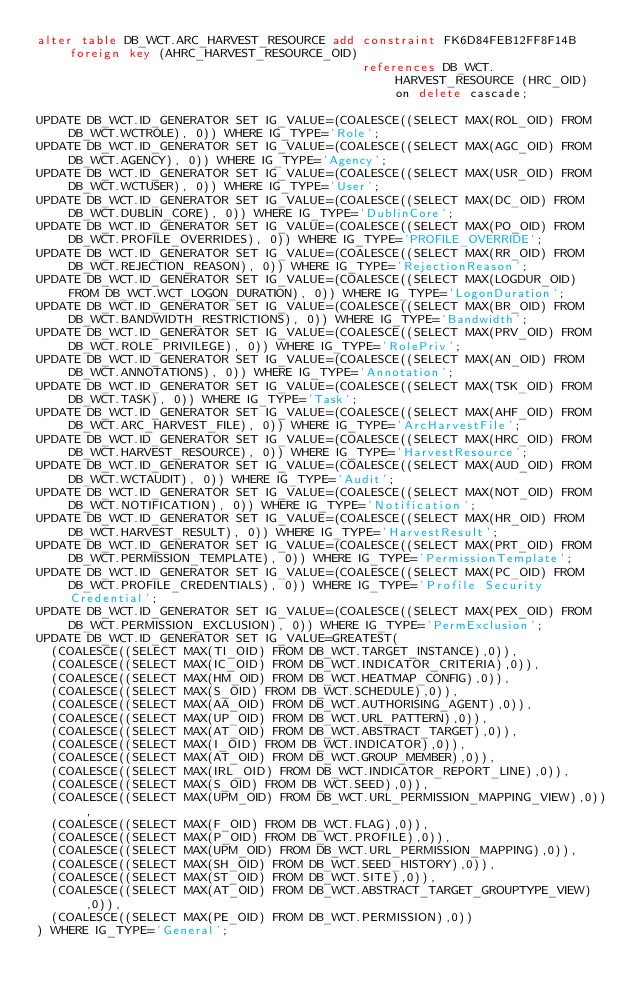<code> <loc_0><loc_0><loc_500><loc_500><_SQL_>alter table DB_WCT.ARC_HARVEST_RESOURCE add constraint FK6D84FEB12FF8F14B foreign key (AHRC_HARVEST_RESOURCE_OID)
                                            references DB_WCT.HARVEST_RESOURCE (HRC_OID) on delete cascade;

UPDATE DB_WCT.ID_GENERATOR SET IG_VALUE=(COALESCE((SELECT MAX(ROL_OID) FROM DB_WCT.WCTROLE), 0)) WHERE IG_TYPE='Role';
UPDATE DB_WCT.ID_GENERATOR SET IG_VALUE=(COALESCE((SELECT MAX(AGC_OID) FROM DB_WCT.AGENCY), 0)) WHERE IG_TYPE='Agency';
UPDATE DB_WCT.ID_GENERATOR SET IG_VALUE=(COALESCE((SELECT MAX(USR_OID) FROM DB_WCT.WCTUSER), 0)) WHERE IG_TYPE='User';
UPDATE DB_WCT.ID_GENERATOR SET IG_VALUE=(COALESCE((SELECT MAX(DC_OID) FROM DB_WCT.DUBLIN_CORE), 0)) WHERE IG_TYPE='DublinCore';
UPDATE DB_WCT.ID_GENERATOR SET IG_VALUE=(COALESCE((SELECT MAX(PO_OID) FROM DB_WCT.PROFILE_OVERRIDES), 0)) WHERE IG_TYPE='PROFILE_OVERRIDE';
UPDATE DB_WCT.ID_GENERATOR SET IG_VALUE=(COALESCE((SELECT MAX(RR_OID) FROM DB_WCT.REJECTION_REASON), 0)) WHERE IG_TYPE='RejectionReason';
UPDATE DB_WCT.ID_GENERATOR SET IG_VALUE=(COALESCE((SELECT MAX(LOGDUR_OID) FROM DB_WCT.WCT_LOGON_DURATION), 0)) WHERE IG_TYPE='LogonDuration';
UPDATE DB_WCT.ID_GENERATOR SET IG_VALUE=(COALESCE((SELECT MAX(BR_OID) FROM DB_WCT.BANDWIDTH_RESTRICTIONS), 0)) WHERE IG_TYPE='Bandwidth';
UPDATE DB_WCT.ID_GENERATOR SET IG_VALUE=(COALESCE((SELECT MAX(PRV_OID) FROM DB_WCT.ROLE_PRIVILEGE), 0)) WHERE IG_TYPE='RolePriv';
UPDATE DB_WCT.ID_GENERATOR SET IG_VALUE=(COALESCE((SELECT MAX(AN_OID) FROM DB_WCT.ANNOTATIONS), 0)) WHERE IG_TYPE='Annotation';
UPDATE DB_WCT.ID_GENERATOR SET IG_VALUE=(COALESCE((SELECT MAX(TSK_OID) FROM DB_WCT.TASK), 0)) WHERE IG_TYPE='Task';
UPDATE DB_WCT.ID_GENERATOR SET IG_VALUE=(COALESCE((SELECT MAX(AHF_OID) FROM DB_WCT.ARC_HARVEST_FILE), 0)) WHERE IG_TYPE='ArcHarvestFile';
UPDATE DB_WCT.ID_GENERATOR SET IG_VALUE=(COALESCE((SELECT MAX(HRC_OID) FROM DB_WCT.HARVEST_RESOURCE), 0)) WHERE IG_TYPE='HarvestResource';
UPDATE DB_WCT.ID_GENERATOR SET IG_VALUE=(COALESCE((SELECT MAX(AUD_OID) FROM DB_WCT.WCTAUDIT), 0)) WHERE IG_TYPE='Audit';
UPDATE DB_WCT.ID_GENERATOR SET IG_VALUE=(COALESCE((SELECT MAX(NOT_OID) FROM DB_WCT.NOTIFICATION), 0)) WHERE IG_TYPE='Notification';
UPDATE DB_WCT.ID_GENERATOR SET IG_VALUE=(COALESCE((SELECT MAX(HR_OID) FROM DB_WCT.HARVEST_RESULT), 0)) WHERE IG_TYPE='HarvestResult';
UPDATE DB_WCT.ID_GENERATOR SET IG_VALUE=(COALESCE((SELECT MAX(PRT_OID) FROM DB_WCT.PERMISSION_TEMPLATE), 0)) WHERE IG_TYPE='PermissionTemplate';
UPDATE DB_WCT.ID_GENERATOR SET IG_VALUE=(COALESCE((SELECT MAX(PC_OID) FROM DB_WCT.PROFILE_CREDENTIALS), 0)) WHERE IG_TYPE='Profile Security Credential';
UPDATE DB_WCT.ID_GENERATOR SET IG_VALUE=(COALESCE((SELECT MAX(PEX_OID) FROM DB_WCT.PERMISSION_EXCLUSION), 0)) WHERE IG_TYPE='PermExclusion';
UPDATE DB_WCT.ID_GENERATOR SET IG_VALUE=GREATEST(
	(COALESCE((SELECT MAX(TI_OID) FROM DB_WCT.TARGET_INSTANCE),0)),
	(COALESCE((SELECT MAX(IC_OID) FROM DB_WCT.INDICATOR_CRITERIA),0)),
	(COALESCE((SELECT MAX(HM_OID) FROM DB_WCT.HEATMAP_CONFIG),0)),
	(COALESCE((SELECT MAX(S_OID) FROM DB_WCT.SCHEDULE),0)),
	(COALESCE((SELECT MAX(AA_OID) FROM DB_WCT.AUTHORISING_AGENT),0)),
	(COALESCE((SELECT MAX(UP_OID) FROM DB_WCT.URL_PATTERN),0)),
	(COALESCE((SELECT MAX(AT_OID) FROM DB_WCT.ABSTRACT_TARGET),0)),
	(COALESCE((SELECT MAX(I_OID) FROM DB_WCT.INDICATOR),0)),
	(COALESCE((SELECT MAX(AT_OID) FROM DB_WCT.GROUP_MEMBER),0)),
	(COALESCE((SELECT MAX(IRL_OID) FROM DB_WCT.INDICATOR_REPORT_LINE),0)),
	(COALESCE((SELECT MAX(S_OID) FROM DB_WCT.SEED),0)),
	(COALESCE((SELECT MAX(UPM_OID) FROM DB_WCT.URL_PERMISSION_MAPPING_VIEW),0)),
	(COALESCE((SELECT MAX(F_OID) FROM DB_WCT.FLAG),0)),
	(COALESCE((SELECT MAX(P_OID) FROM DB_WCT.PROFILE),0)),
	(COALESCE((SELECT MAX(UPM_OID) FROM DB_WCT.URL_PERMISSION_MAPPING),0)),
	(COALESCE((SELECT MAX(SH_OID) FROM DB_WCT.SEED_HISTORY),0)),
	(COALESCE((SELECT MAX(ST_OID) FROM DB_WCT.SITE),0)),
	(COALESCE((SELECT MAX(AT_OID) FROM DB_WCT.ABSTRACT_TARGET_GROUPTYPE_VIEW),0)),
	(COALESCE((SELECT MAX(PE_OID) FROM DB_WCT.PERMISSION),0))
) WHERE IG_TYPE='General';

</code> 